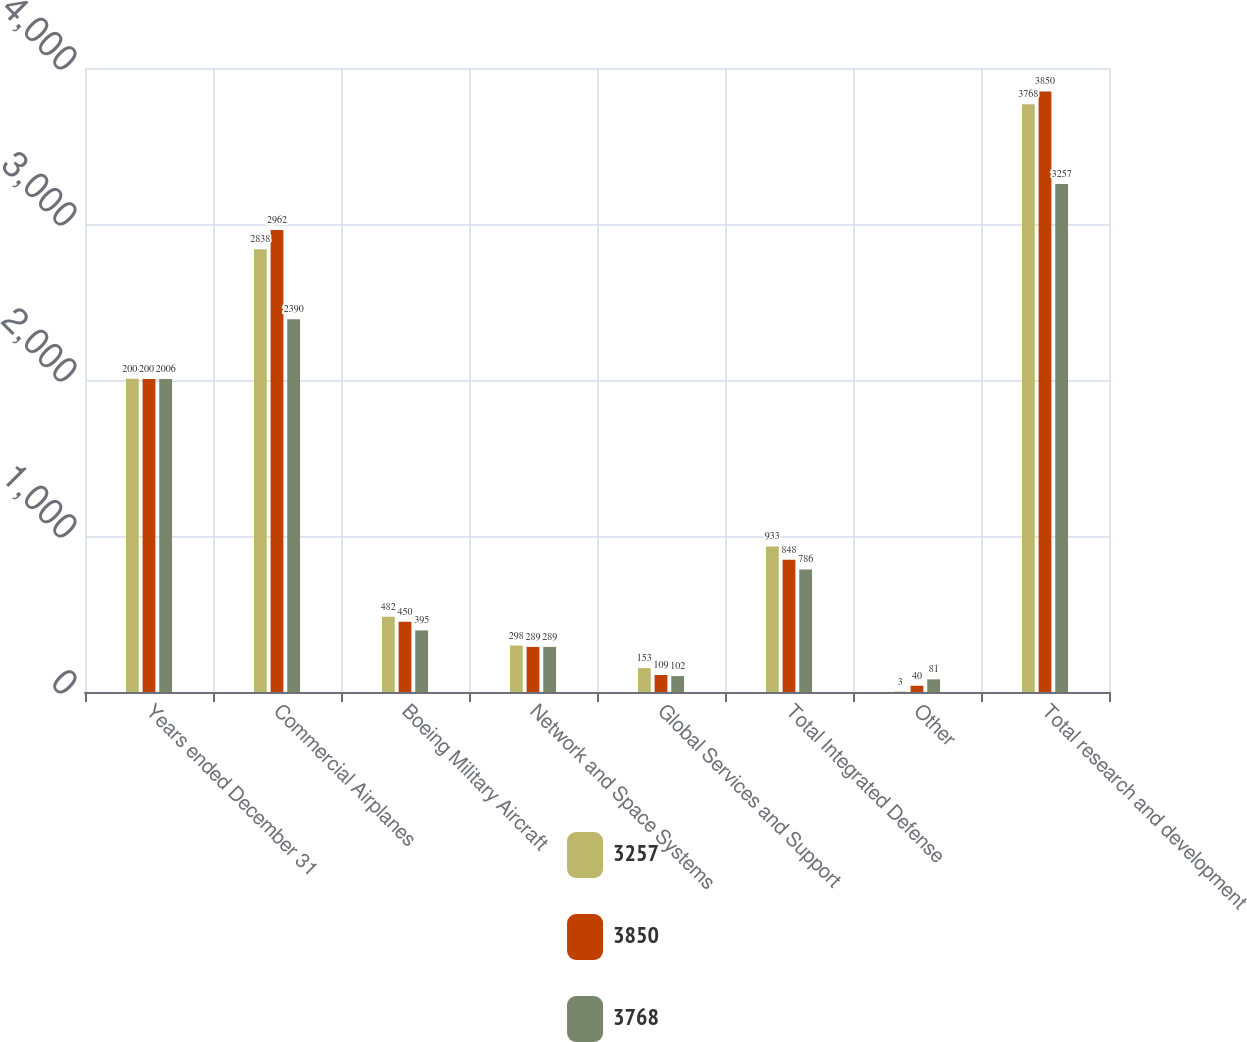Convert chart to OTSL. <chart><loc_0><loc_0><loc_500><loc_500><stacked_bar_chart><ecel><fcel>Years ended December 31<fcel>Commercial Airplanes<fcel>Boeing Military Aircraft<fcel>Network and Space Systems<fcel>Global Services and Support<fcel>Total Integrated Defense<fcel>Other<fcel>Total research and development<nl><fcel>3257<fcel>2008<fcel>2838<fcel>482<fcel>298<fcel>153<fcel>933<fcel>3<fcel>3768<nl><fcel>3850<fcel>2007<fcel>2962<fcel>450<fcel>289<fcel>109<fcel>848<fcel>40<fcel>3850<nl><fcel>3768<fcel>2006<fcel>2390<fcel>395<fcel>289<fcel>102<fcel>786<fcel>81<fcel>3257<nl></chart> 